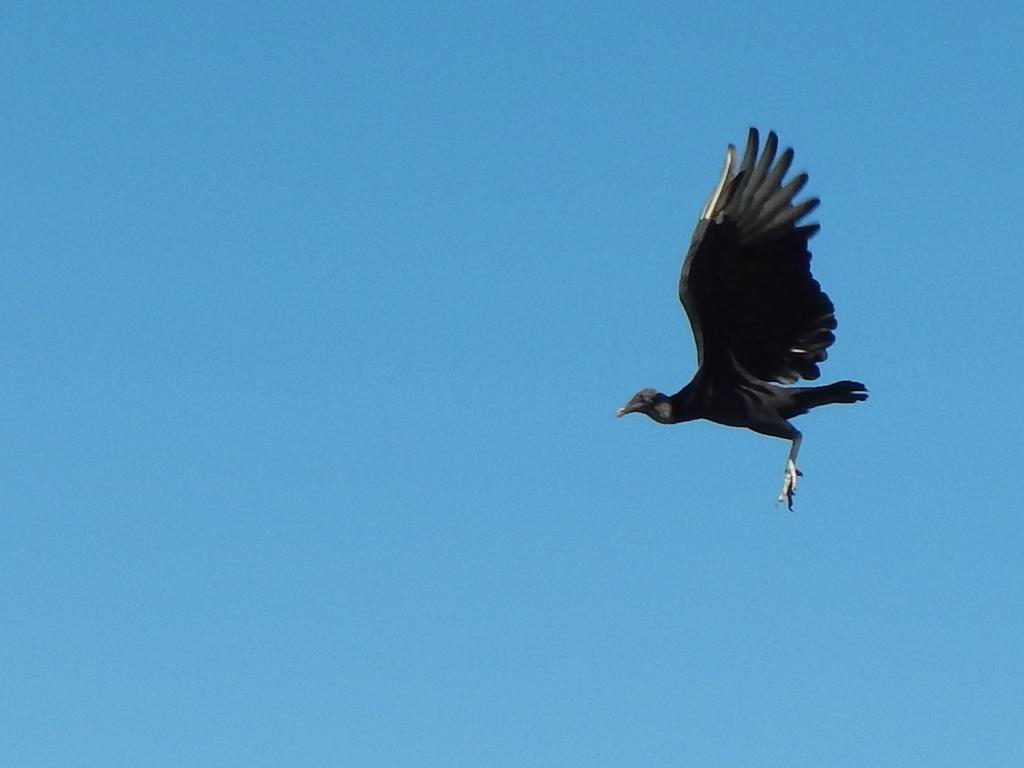What is the main subject of the image? The main subject of the image is a bird flying. What can be seen in the background of the image? The sky is blue in the background of the image. What type of glue is being used by the bird in the image? There is no glue present in the image, as it features a bird flying in the sky. What fact can be determined about the bird's approval rating in the image? There is no information about the bird's approval rating in the image, as it is focused on the bird flying. 